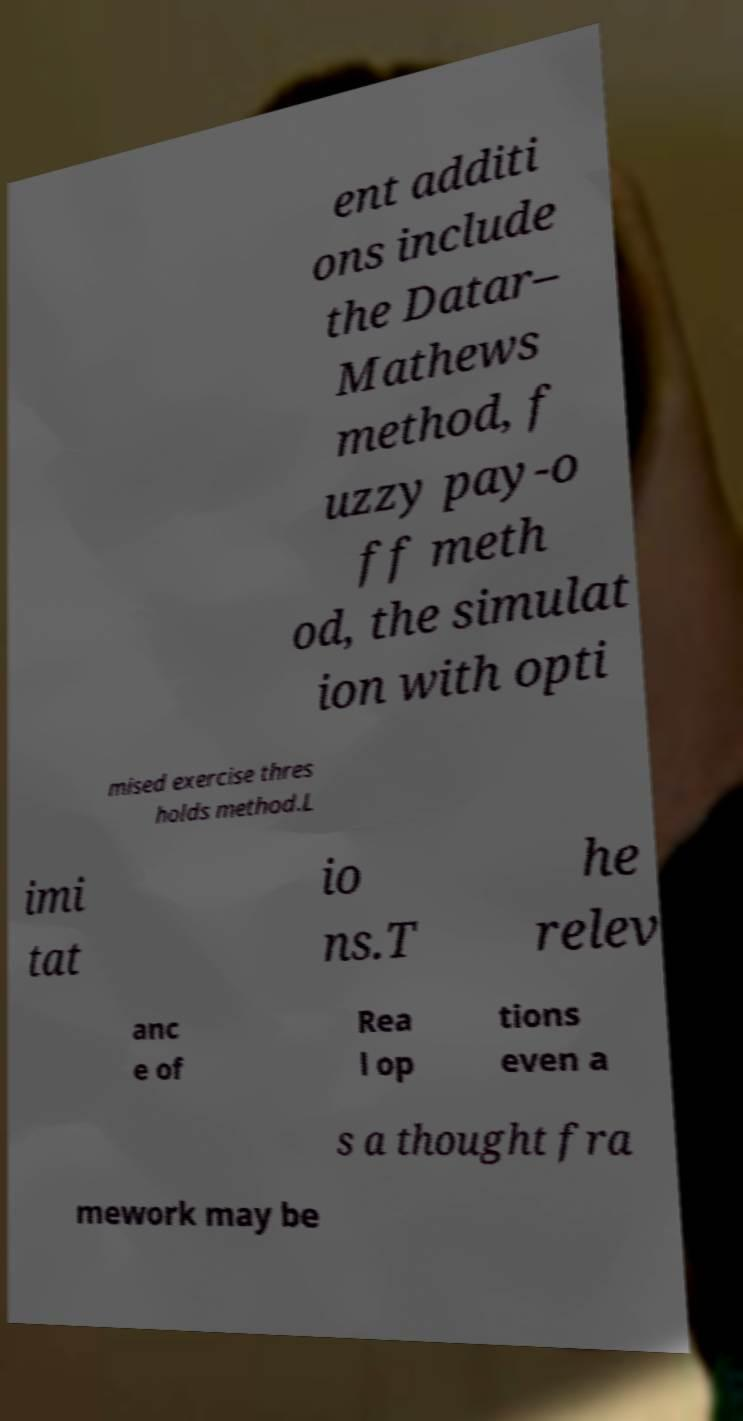I need the written content from this picture converted into text. Can you do that? ent additi ons include the Datar– Mathews method, f uzzy pay-o ff meth od, the simulat ion with opti mised exercise thres holds method.L imi tat io ns.T he relev anc e of Rea l op tions even a s a thought fra mework may be 